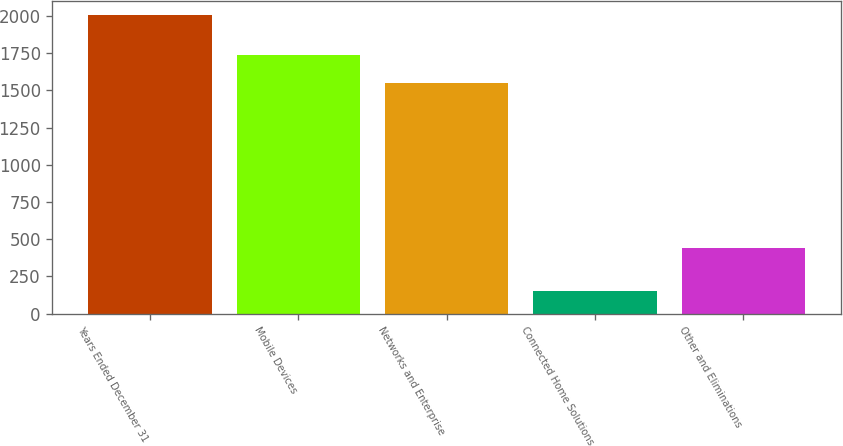<chart> <loc_0><loc_0><loc_500><loc_500><bar_chart><fcel>Years Ended December 31<fcel>Mobile Devices<fcel>Networks and Enterprise<fcel>Connected Home Solutions<fcel>Other and Eliminations<nl><fcel>2004<fcel>1735<fcel>1550<fcel>154<fcel>440<nl></chart> 